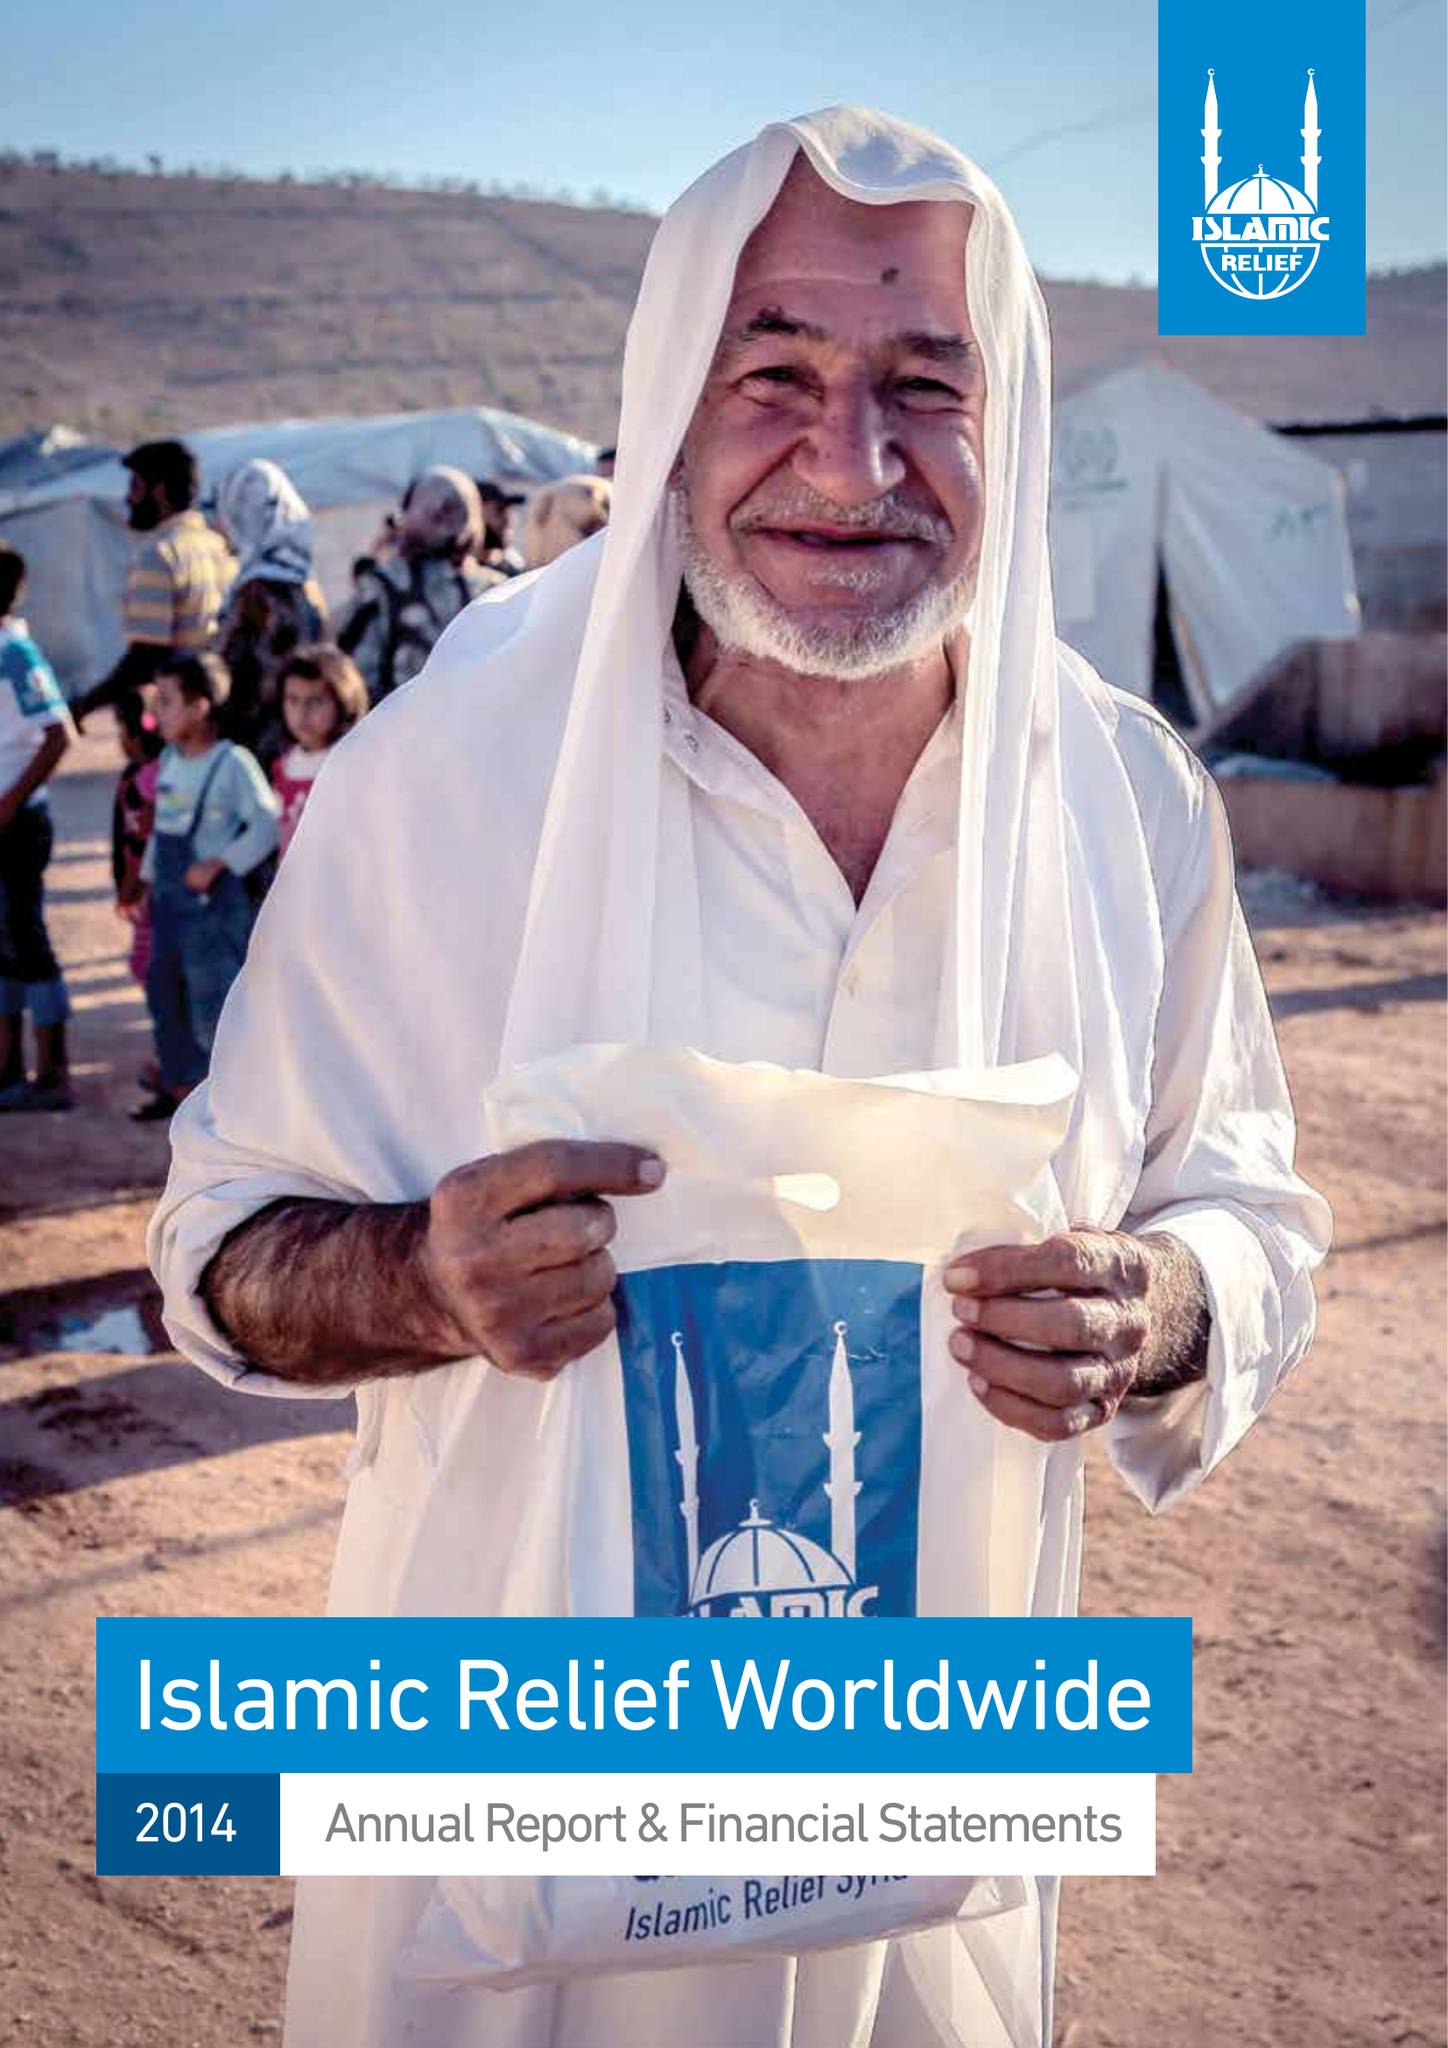What is the value for the report_date?
Answer the question using a single word or phrase. 2014-12-31 